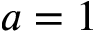Convert formula to latex. <formula><loc_0><loc_0><loc_500><loc_500>a = 1</formula> 